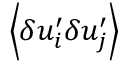<formula> <loc_0><loc_0><loc_500><loc_500>\, \left \langle { \delta u _ { i } ^ { \prime } \delta u _ { j } ^ { \prime } } \right \rangle</formula> 